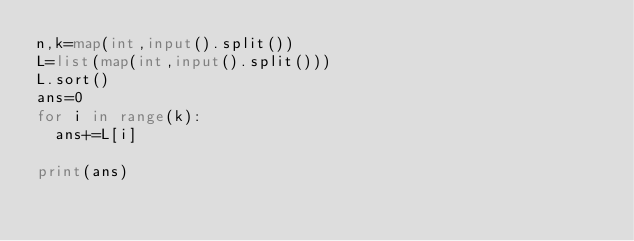Convert code to text. <code><loc_0><loc_0><loc_500><loc_500><_Python_>n,k=map(int,input().split())
L=list(map(int,input().split()))
L.sort()
ans=0
for i in range(k):
  ans+=L[i]

print(ans)</code> 